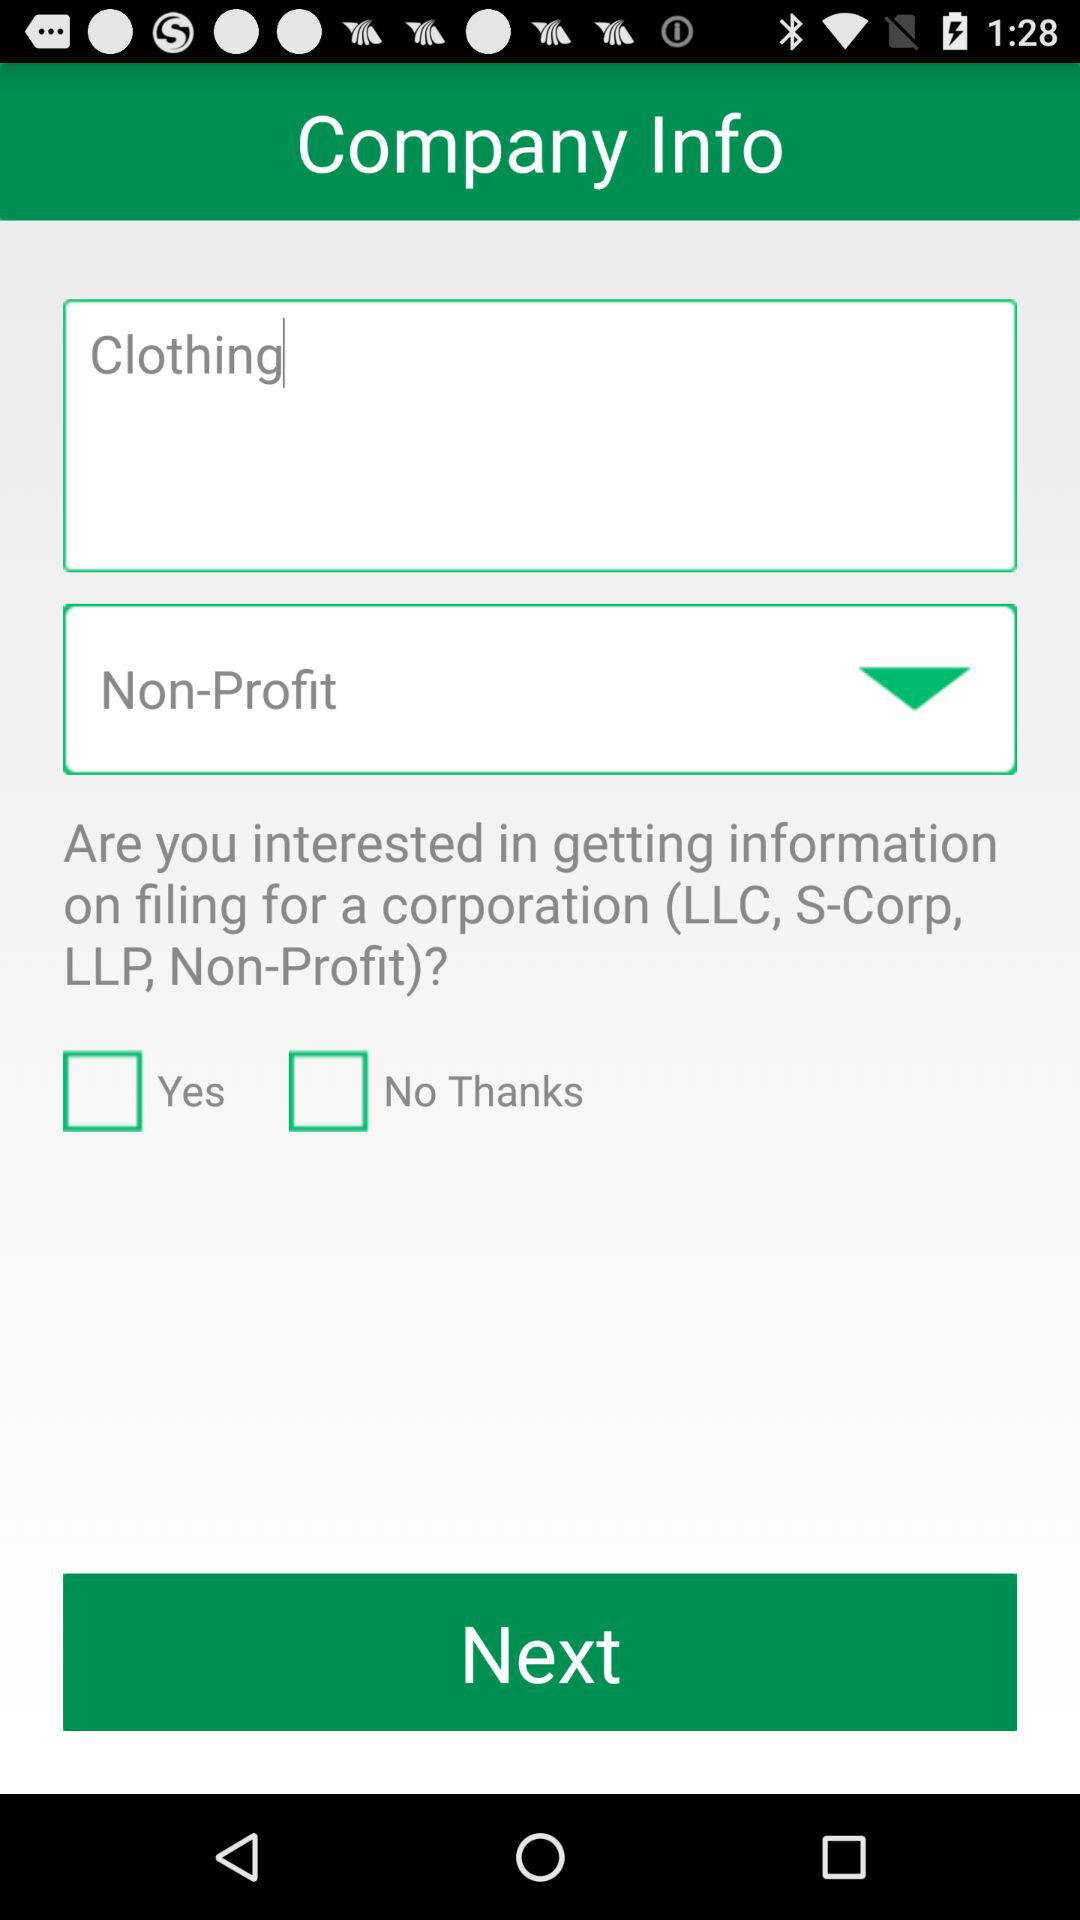Which options are not selected? The options "Yes" and "No Thanks" are not selected. 